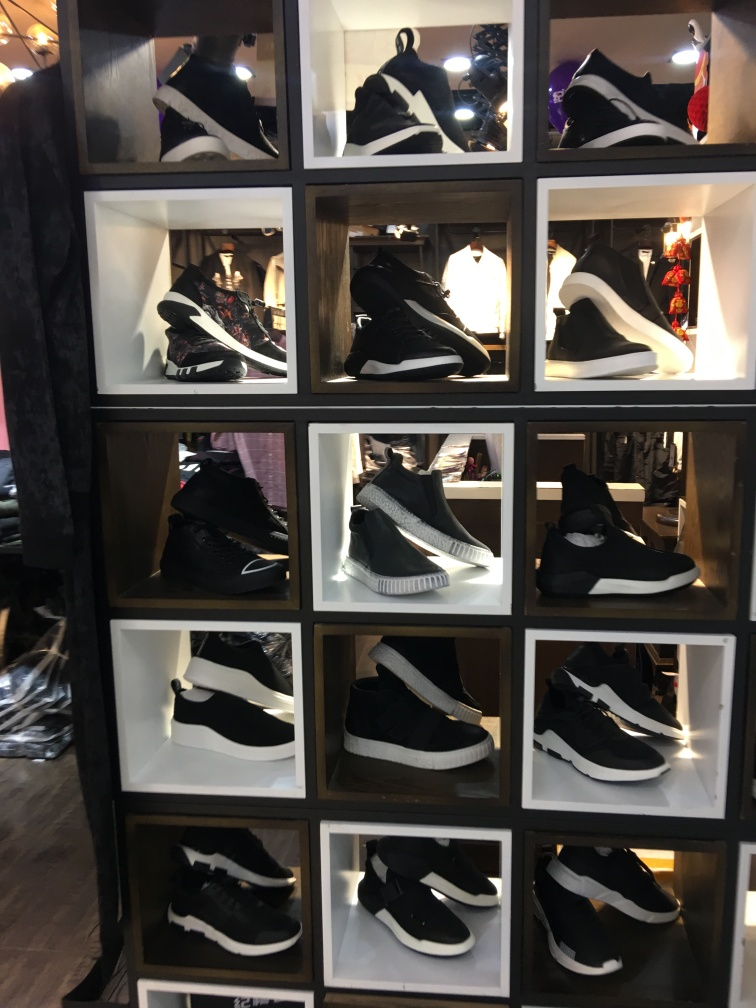What can you tell about the presentation of the products in this image? The sneakers are neatly organized in individual compartments within a display shelf. This type of presentation accentuates each pair's design, makes it easy for customers to view different options, and contributes to an orderly and attractive retail environment. The uniform color scheme of black and white further adds a sense of sophistication and brand consistency. 